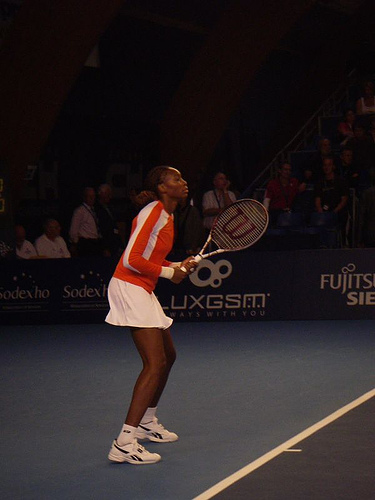<image>What color are her pants? It is ambiguous what color her pants are. They could be white. What color are her pants? The pants are white. 